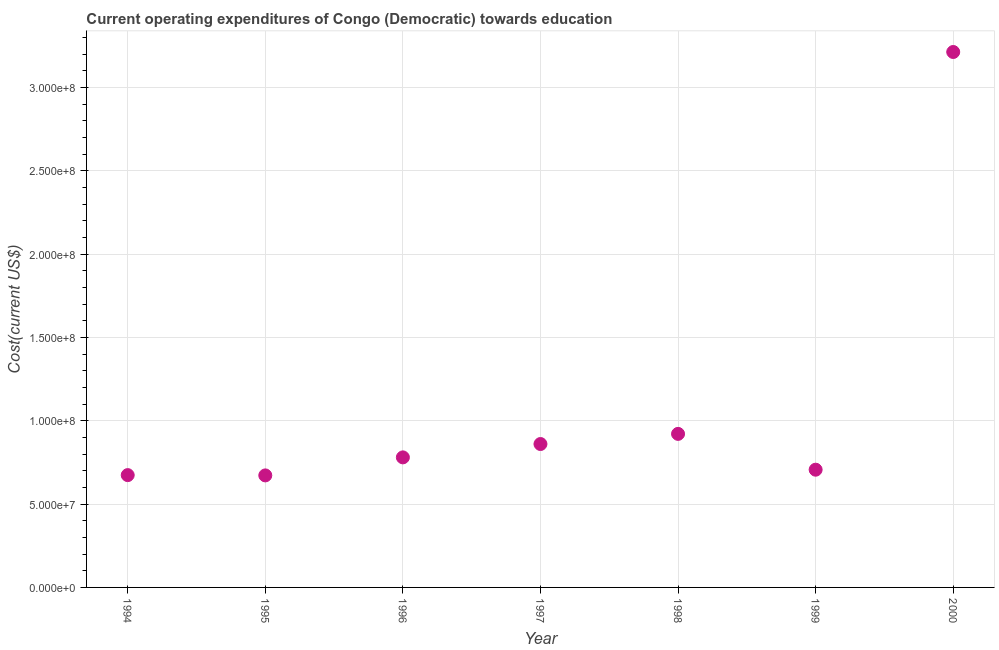What is the education expenditure in 1997?
Keep it short and to the point. 8.61e+07. Across all years, what is the maximum education expenditure?
Provide a short and direct response. 3.21e+08. Across all years, what is the minimum education expenditure?
Your answer should be very brief. 6.72e+07. In which year was the education expenditure maximum?
Ensure brevity in your answer.  2000. In which year was the education expenditure minimum?
Provide a short and direct response. 1995. What is the sum of the education expenditure?
Give a very brief answer. 7.83e+08. What is the difference between the education expenditure in 1994 and 1998?
Give a very brief answer. -2.47e+07. What is the average education expenditure per year?
Offer a terse response. 1.12e+08. What is the median education expenditure?
Offer a terse response. 7.80e+07. In how many years, is the education expenditure greater than 50000000 US$?
Provide a succinct answer. 7. Do a majority of the years between 2000 and 1999 (inclusive) have education expenditure greater than 230000000 US$?
Offer a very short reply. No. What is the ratio of the education expenditure in 1998 to that in 1999?
Give a very brief answer. 1.3. Is the difference between the education expenditure in 1994 and 1996 greater than the difference between any two years?
Keep it short and to the point. No. What is the difference between the highest and the second highest education expenditure?
Offer a terse response. 2.29e+08. Is the sum of the education expenditure in 1997 and 1999 greater than the maximum education expenditure across all years?
Make the answer very short. No. What is the difference between the highest and the lowest education expenditure?
Provide a succinct answer. 2.54e+08. Does the education expenditure monotonically increase over the years?
Your response must be concise. No. What is the difference between two consecutive major ticks on the Y-axis?
Make the answer very short. 5.00e+07. Does the graph contain any zero values?
Keep it short and to the point. No. What is the title of the graph?
Your answer should be compact. Current operating expenditures of Congo (Democratic) towards education. What is the label or title of the Y-axis?
Ensure brevity in your answer.  Cost(current US$). What is the Cost(current US$) in 1994?
Offer a very short reply. 6.74e+07. What is the Cost(current US$) in 1995?
Keep it short and to the point. 6.72e+07. What is the Cost(current US$) in 1996?
Your response must be concise. 7.80e+07. What is the Cost(current US$) in 1997?
Provide a succinct answer. 8.61e+07. What is the Cost(current US$) in 1998?
Your answer should be very brief. 9.21e+07. What is the Cost(current US$) in 1999?
Offer a very short reply. 7.06e+07. What is the Cost(current US$) in 2000?
Offer a terse response. 3.21e+08. What is the difference between the Cost(current US$) in 1994 and 1995?
Give a very brief answer. 1.75e+05. What is the difference between the Cost(current US$) in 1994 and 1996?
Your response must be concise. -1.06e+07. What is the difference between the Cost(current US$) in 1994 and 1997?
Keep it short and to the point. -1.87e+07. What is the difference between the Cost(current US$) in 1994 and 1998?
Your response must be concise. -2.47e+07. What is the difference between the Cost(current US$) in 1994 and 1999?
Make the answer very short. -3.25e+06. What is the difference between the Cost(current US$) in 1994 and 2000?
Offer a terse response. -2.54e+08. What is the difference between the Cost(current US$) in 1995 and 1996?
Your answer should be compact. -1.08e+07. What is the difference between the Cost(current US$) in 1995 and 1997?
Your response must be concise. -1.88e+07. What is the difference between the Cost(current US$) in 1995 and 1998?
Your response must be concise. -2.49e+07. What is the difference between the Cost(current US$) in 1995 and 1999?
Ensure brevity in your answer.  -3.42e+06. What is the difference between the Cost(current US$) in 1995 and 2000?
Your answer should be compact. -2.54e+08. What is the difference between the Cost(current US$) in 1996 and 1997?
Your answer should be compact. -8.01e+06. What is the difference between the Cost(current US$) in 1996 and 1998?
Provide a succinct answer. -1.41e+07. What is the difference between the Cost(current US$) in 1996 and 1999?
Provide a short and direct response. 7.40e+06. What is the difference between the Cost(current US$) in 1996 and 2000?
Give a very brief answer. -2.43e+08. What is the difference between the Cost(current US$) in 1997 and 1998?
Provide a succinct answer. -6.09e+06. What is the difference between the Cost(current US$) in 1997 and 1999?
Ensure brevity in your answer.  1.54e+07. What is the difference between the Cost(current US$) in 1997 and 2000?
Keep it short and to the point. -2.35e+08. What is the difference between the Cost(current US$) in 1998 and 1999?
Keep it short and to the point. 2.15e+07. What is the difference between the Cost(current US$) in 1998 and 2000?
Offer a terse response. -2.29e+08. What is the difference between the Cost(current US$) in 1999 and 2000?
Give a very brief answer. -2.51e+08. What is the ratio of the Cost(current US$) in 1994 to that in 1996?
Your response must be concise. 0.86. What is the ratio of the Cost(current US$) in 1994 to that in 1997?
Give a very brief answer. 0.78. What is the ratio of the Cost(current US$) in 1994 to that in 1998?
Your answer should be very brief. 0.73. What is the ratio of the Cost(current US$) in 1994 to that in 1999?
Make the answer very short. 0.95. What is the ratio of the Cost(current US$) in 1994 to that in 2000?
Your answer should be compact. 0.21. What is the ratio of the Cost(current US$) in 1995 to that in 1996?
Keep it short and to the point. 0.86. What is the ratio of the Cost(current US$) in 1995 to that in 1997?
Ensure brevity in your answer.  0.78. What is the ratio of the Cost(current US$) in 1995 to that in 1998?
Keep it short and to the point. 0.73. What is the ratio of the Cost(current US$) in 1995 to that in 1999?
Offer a terse response. 0.95. What is the ratio of the Cost(current US$) in 1995 to that in 2000?
Ensure brevity in your answer.  0.21. What is the ratio of the Cost(current US$) in 1996 to that in 1997?
Make the answer very short. 0.91. What is the ratio of the Cost(current US$) in 1996 to that in 1998?
Your response must be concise. 0.85. What is the ratio of the Cost(current US$) in 1996 to that in 1999?
Offer a very short reply. 1.1. What is the ratio of the Cost(current US$) in 1996 to that in 2000?
Ensure brevity in your answer.  0.24. What is the ratio of the Cost(current US$) in 1997 to that in 1998?
Keep it short and to the point. 0.93. What is the ratio of the Cost(current US$) in 1997 to that in 1999?
Give a very brief answer. 1.22. What is the ratio of the Cost(current US$) in 1997 to that in 2000?
Offer a very short reply. 0.27. What is the ratio of the Cost(current US$) in 1998 to that in 1999?
Offer a very short reply. 1.3. What is the ratio of the Cost(current US$) in 1998 to that in 2000?
Provide a short and direct response. 0.29. What is the ratio of the Cost(current US$) in 1999 to that in 2000?
Provide a short and direct response. 0.22. 